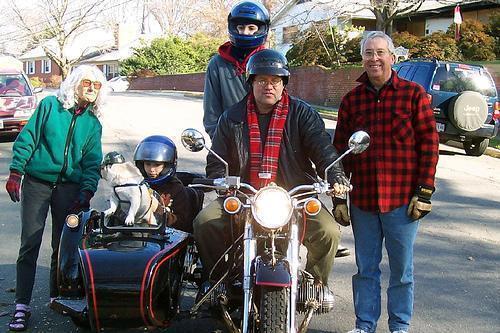What is the little dog wearing in the sidecar?
Choose the correct response, then elucidate: 'Answer: answer
Rationale: rationale.'
Options: Helmet, scarf, hat, tshirt. Answer: helmet.
Rationale: It has a small helmet. 